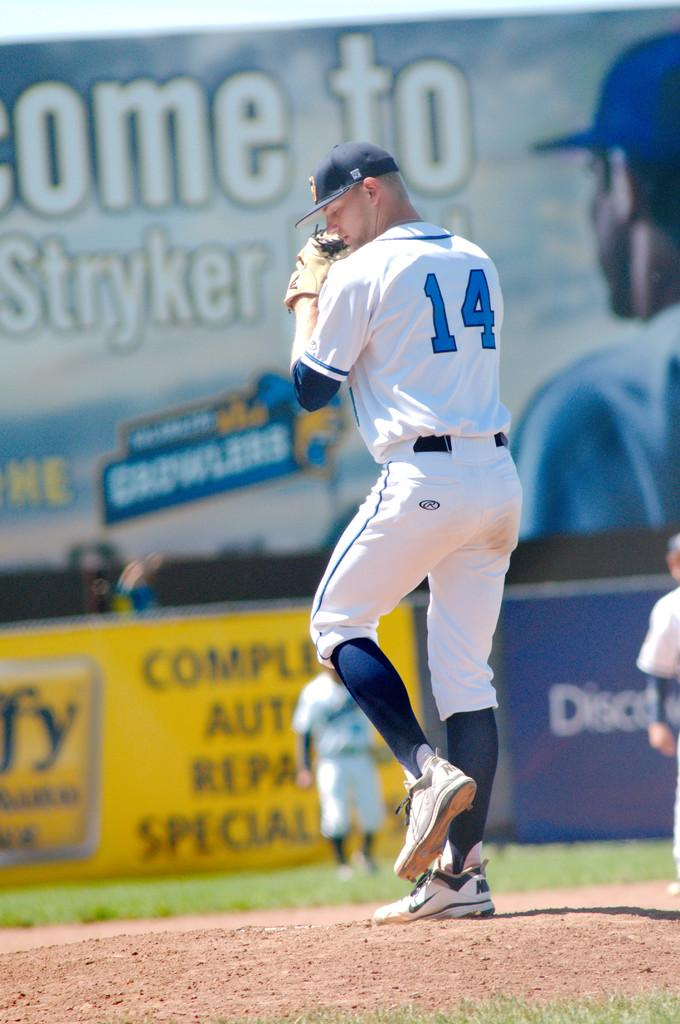Provide a one-sentence caption for the provided image. A baseball player getting ready to pitch with Stryker advertising in the back. 